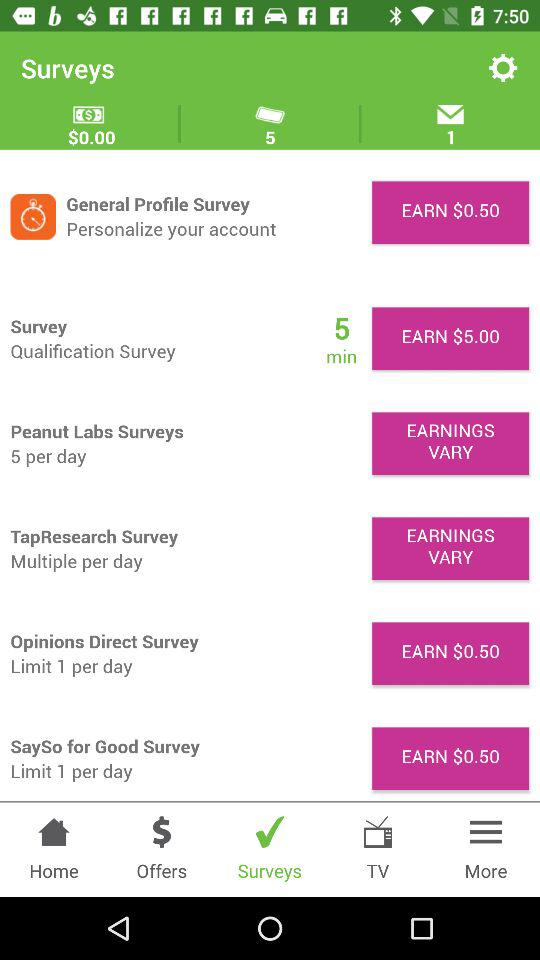How many unread messages are there? There is 1 unread message. 